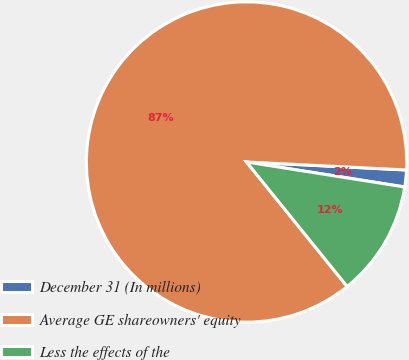<chart> <loc_0><loc_0><loc_500><loc_500><pie_chart><fcel>December 31 (In millions)<fcel>Average GE shareowners' equity<fcel>Less the effects of the<nl><fcel>1.7%<fcel>86.61%<fcel>11.69%<nl></chart> 